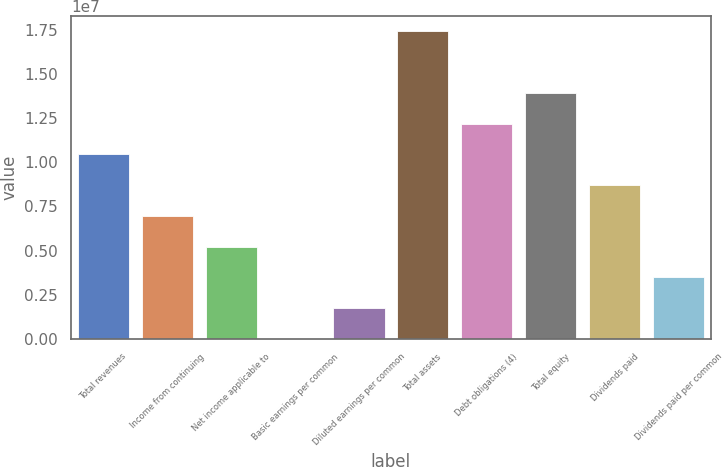Convert chart to OTSL. <chart><loc_0><loc_0><loc_500><loc_500><bar_chart><fcel>Total revenues<fcel>Income from continuing<fcel>Net income applicable to<fcel>Basic earnings per common<fcel>Diluted earnings per common<fcel>Total assets<fcel>Debt obligations (4)<fcel>Total equity<fcel>Dividends paid<fcel>Dividends paid per common<nl><fcel>1.04451e+07<fcel>6.96339e+06<fcel>5.22254e+06<fcel>1.25<fcel>1.74085e+06<fcel>1.74085e+07<fcel>1.21859e+07<fcel>1.39268e+07<fcel>8.70424e+06<fcel>3.4817e+06<nl></chart> 